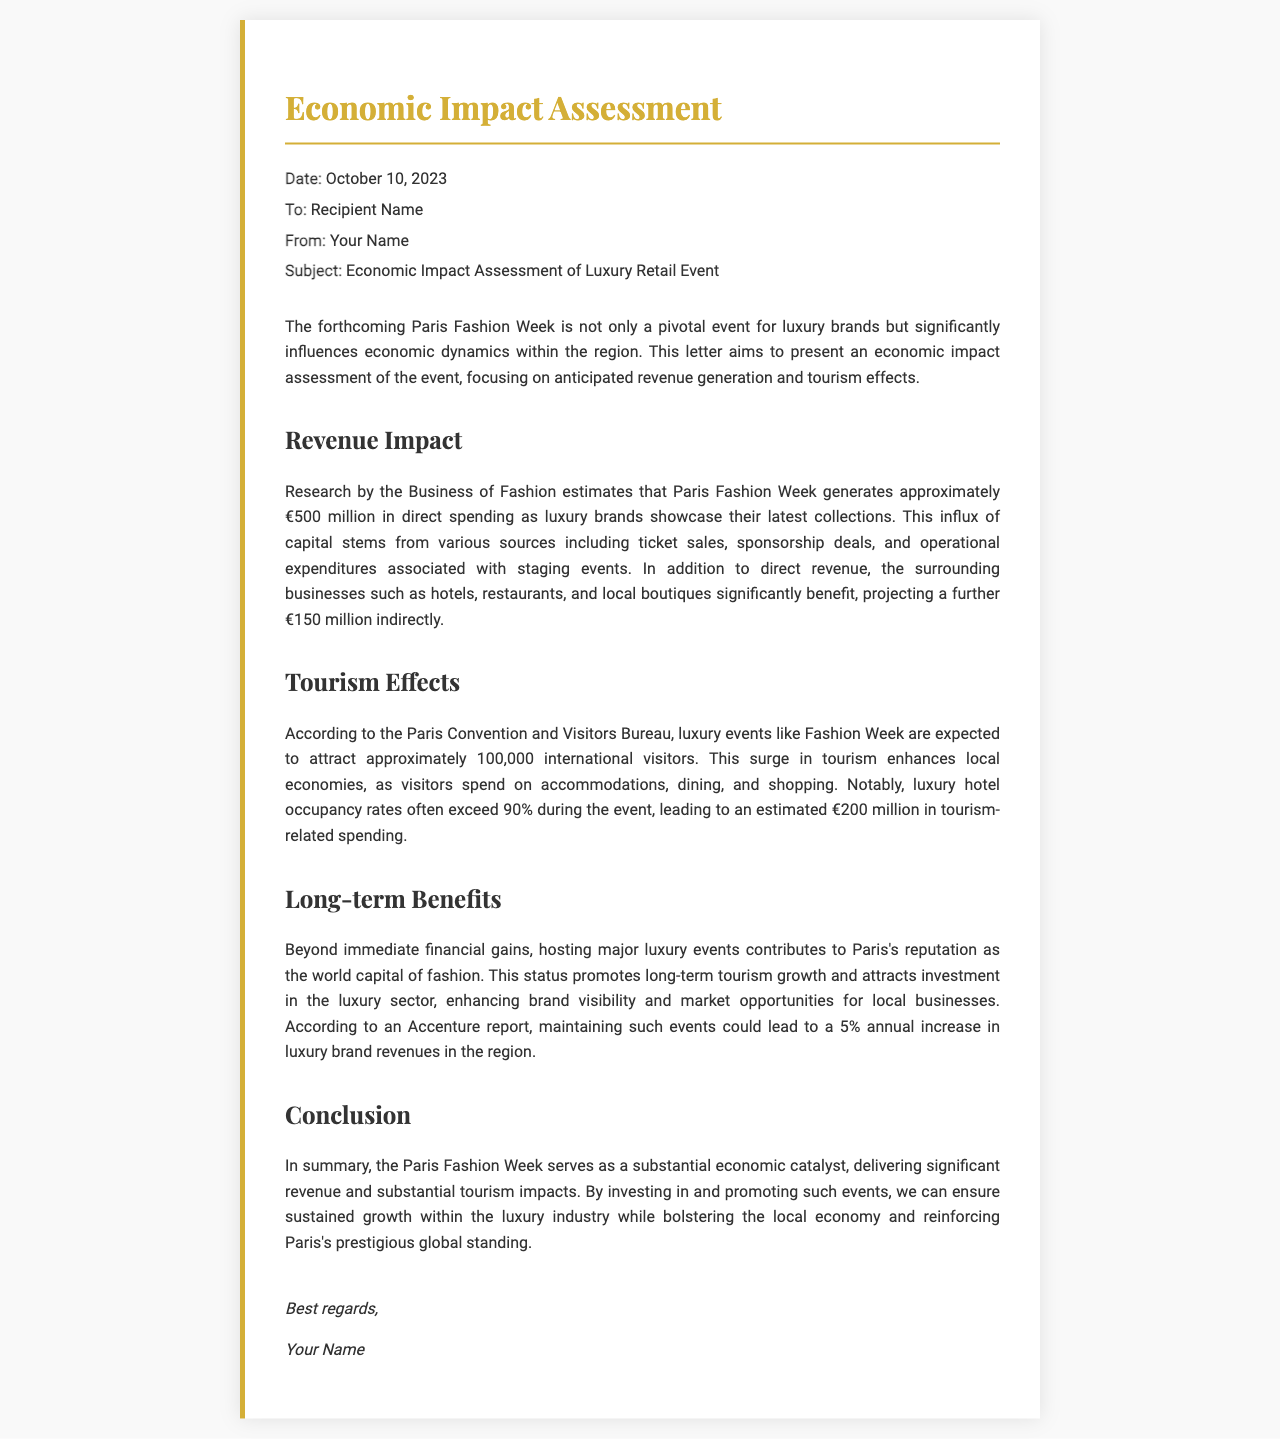What is the date of the letter? The date is explicitly mentioned in the header of the letter.
Answer: October 10, 2023 What is the expected direct spending generated by Paris Fashion Week? The direct spending figure is provided under the revenue impact section.
Answer: €500 million How much indirect revenue is projected for surrounding businesses? This information is found along with the direct spending data in the same section.
Answer: €150 million How many international visitors are expected during the event? The number of expected visitors is noted under the tourism effects section.
Answer: 100,000 What is the estimated tourism-related spending during the event? The specific financial figure is provided in relation to tourism effects in the document.
Answer: €200 million What is the luxury hotel occupancy rate during the event? This detail about hotel occupancy is noted in the tourism effects section.
Answer: 90% What annual increase in luxury brand revenues could maintaining such events lead to? This projection is stated in the long-term benefits section.
Answer: 5% Who is the sender of the letter? The sender's name is mentioned in the signature area.
Answer: Your Name What is the primary subject of the letter? The subject line in the header highlights the focus of the letter.
Answer: Economic Impact Assessment of Luxury Retail Event 